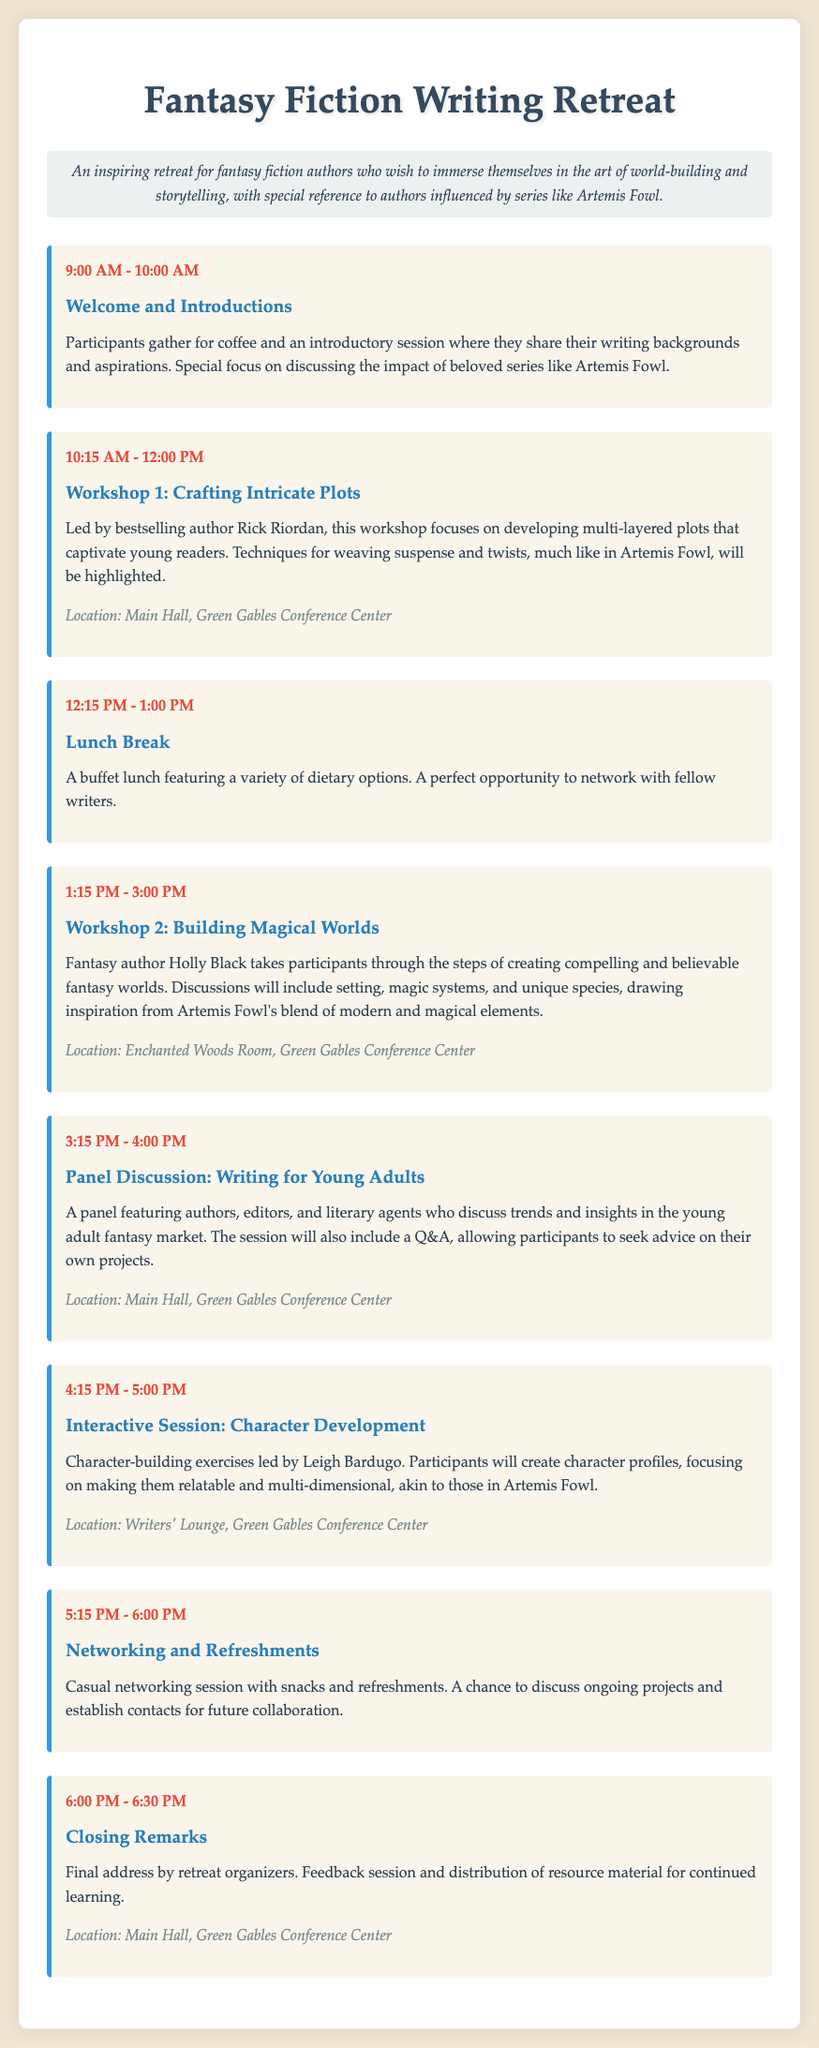What time does the retreat start? The retreat starts with a welcome and introductions session at 9:00 AM.
Answer: 9:00 AM Who is leading Workshop 1? Workshop 1 is led by bestselling author Rick Riordan.
Answer: Rick Riordan What is the location for the Interactive Session? The Interactive Session on character development takes place in the Writers' Lounge.
Answer: Writers' Lounge What is the duration of the Lunch Break? The Lunch Break is from 12:15 PM to 1:00 PM, which is 45 minutes long.
Answer: 45 minutes Which author conducts the workshop on building magical worlds? Holly Black conducts the workshop on building magical worlds.
Answer: Holly Black What is one topic discussed in the Panel Discussion? The Panel Discussion includes trends and insights in the young adult fantasy market.
Answer: Young adult fantasy market What activity follows the Networking and Refreshments session? After the Networking and Refreshments session, there are Closing Remarks.
Answer: Closing Remarks How many workshops are scheduled for the retreat? There are two workshops scheduled for the retreat.
Answer: Two 